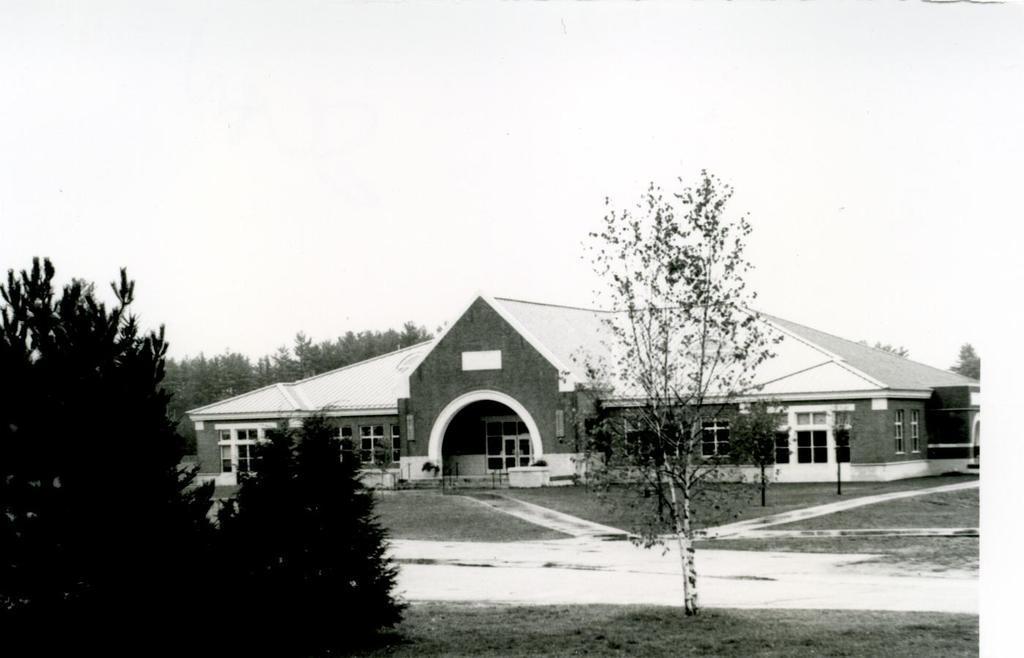How would you summarize this image in a sentence or two? In this picture I can see there is a building, it has windows and doors. There are few trees at left and there is snow on the floor and the sky is clear. 